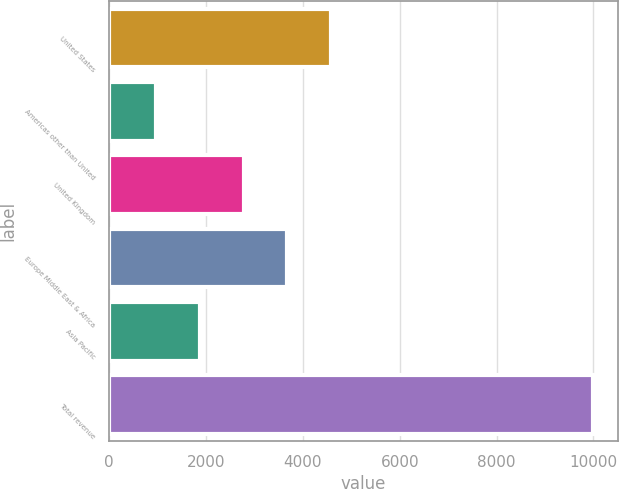Convert chart. <chart><loc_0><loc_0><loc_500><loc_500><bar_chart><fcel>United States<fcel>Americas other than United<fcel>United Kingdom<fcel>Europe Middle East & Africa<fcel>Asia Pacific<fcel>Total revenue<nl><fcel>4584.8<fcel>976<fcel>2780.4<fcel>3682.6<fcel>1878.2<fcel>9998<nl></chart> 